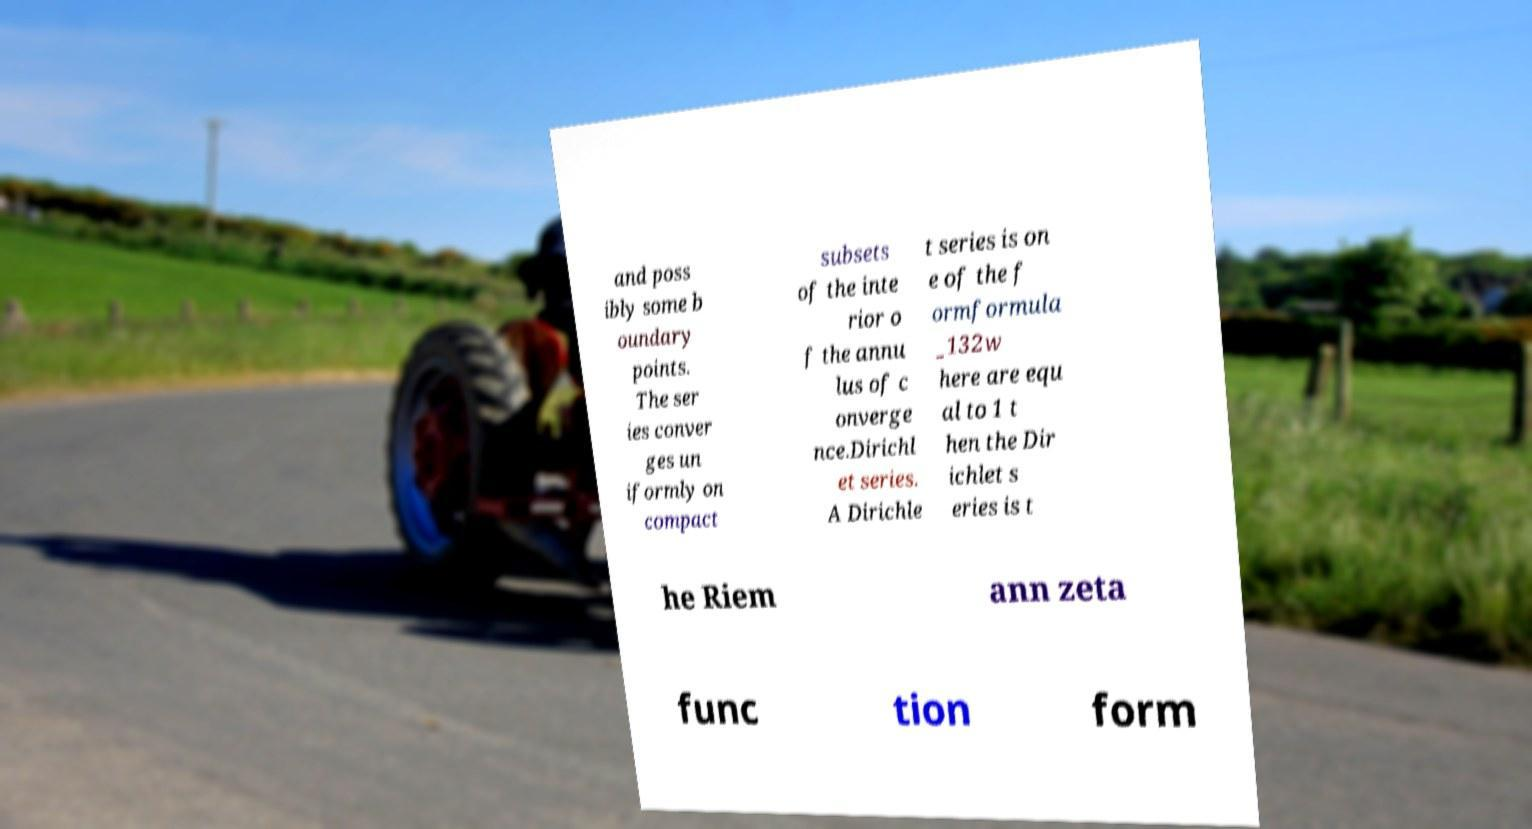Please identify and transcribe the text found in this image. and poss ibly some b oundary points. The ser ies conver ges un iformly on compact subsets of the inte rior o f the annu lus of c onverge nce.Dirichl et series. A Dirichle t series is on e of the f ormformula _132w here are equ al to 1 t hen the Dir ichlet s eries is t he Riem ann zeta func tion form 